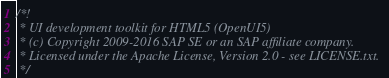Convert code to text. <code><loc_0><loc_0><loc_500><loc_500><_JavaScript_>/*!
 * UI development toolkit for HTML5 (OpenUI5)
 * (c) Copyright 2009-2016 SAP SE or an SAP affiliate company.
 * Licensed under the Apache License, Version 2.0 - see LICENSE.txt.
 */</code> 